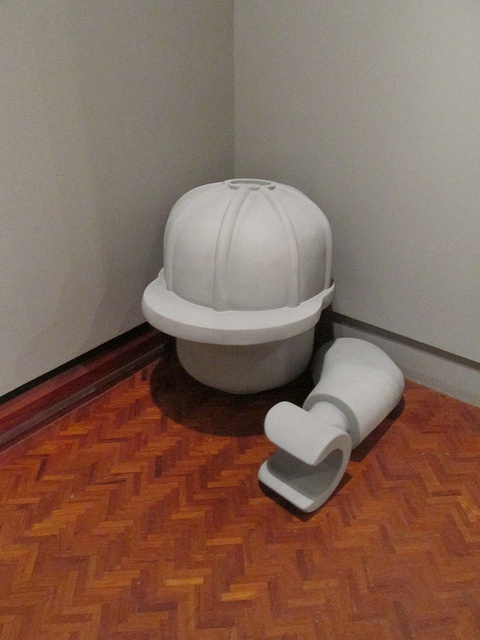Describe the objects in this image and their specific colors. I can see a toilet in gray, darkgray, and black tones in this image. 